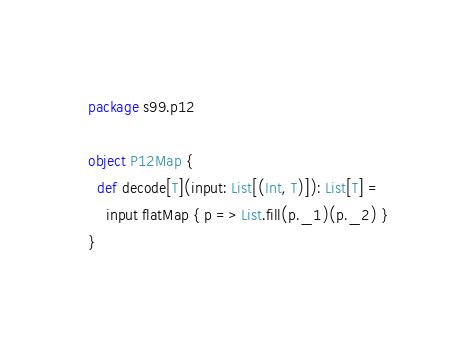<code> <loc_0><loc_0><loc_500><loc_500><_Scala_>package s99.p12

object P12Map {
  def decode[T](input: List[(Int, T)]): List[T] =
    input flatMap { p => List.fill(p._1)(p._2) }
}</code> 